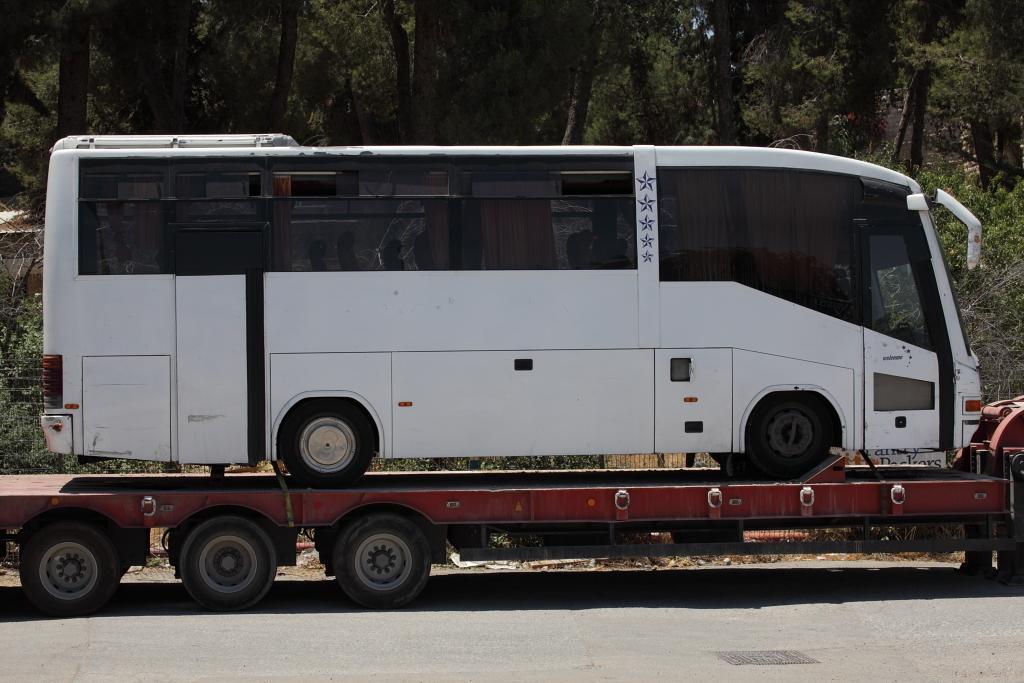Could you give a brief overview of what you see in this image? In the background we can see the trees. In this picture we can see a bus is placed on the platform of a vehicle. At the bottom portion of the picture we can see the road. 